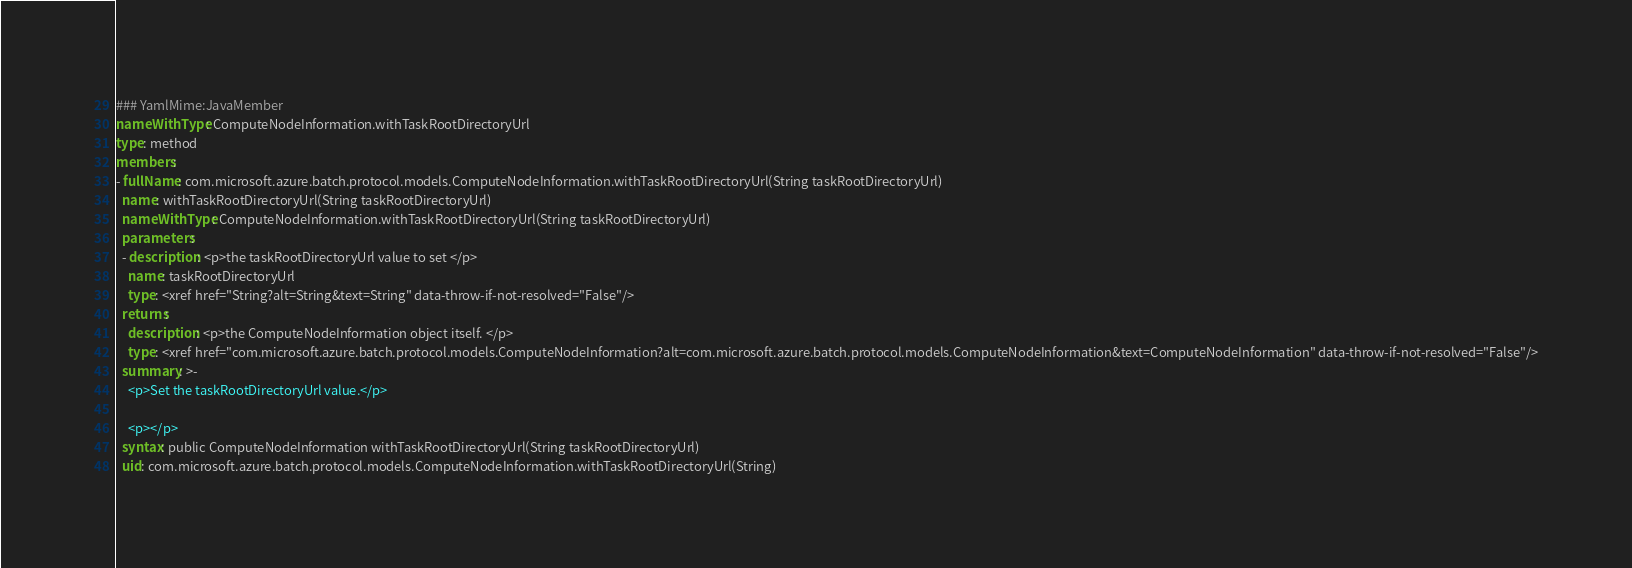<code> <loc_0><loc_0><loc_500><loc_500><_YAML_>### YamlMime:JavaMember
nameWithType: ComputeNodeInformation.withTaskRootDirectoryUrl
type: method
members:
- fullName: com.microsoft.azure.batch.protocol.models.ComputeNodeInformation.withTaskRootDirectoryUrl(String taskRootDirectoryUrl)
  name: withTaskRootDirectoryUrl(String taskRootDirectoryUrl)
  nameWithType: ComputeNodeInformation.withTaskRootDirectoryUrl(String taskRootDirectoryUrl)
  parameters:
  - description: <p>the taskRootDirectoryUrl value to set </p>
    name: taskRootDirectoryUrl
    type: <xref href="String?alt=String&text=String" data-throw-if-not-resolved="False"/>
  returns:
    description: <p>the ComputeNodeInformation object itself. </p>
    type: <xref href="com.microsoft.azure.batch.protocol.models.ComputeNodeInformation?alt=com.microsoft.azure.batch.protocol.models.ComputeNodeInformation&text=ComputeNodeInformation" data-throw-if-not-resolved="False"/>
  summary: >-
    <p>Set the taskRootDirectoryUrl value.</p>

    <p></p>
  syntax: public ComputeNodeInformation withTaskRootDirectoryUrl(String taskRootDirectoryUrl)
  uid: com.microsoft.azure.batch.protocol.models.ComputeNodeInformation.withTaskRootDirectoryUrl(String)</code> 